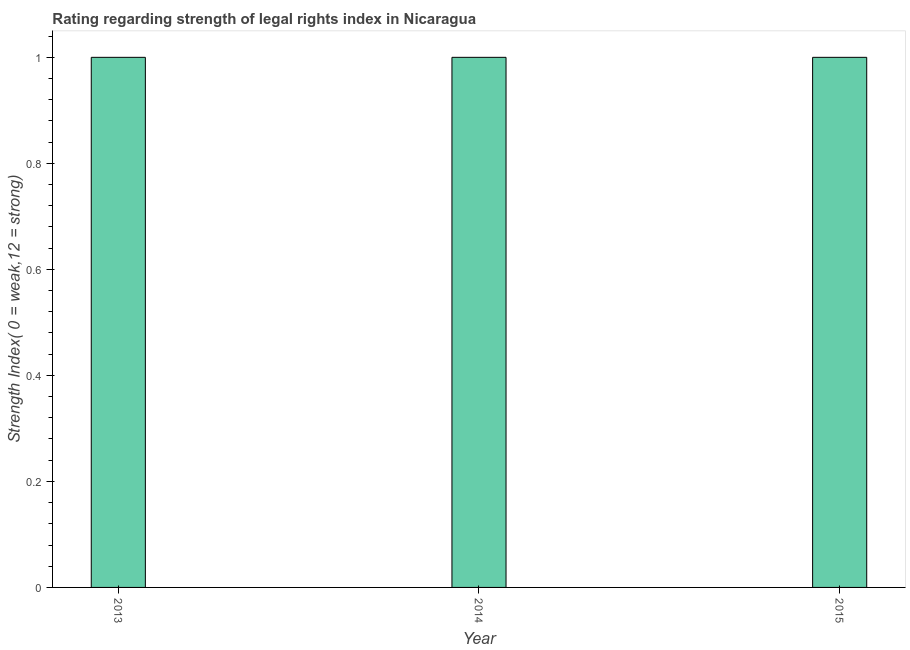Does the graph contain grids?
Offer a very short reply. No. What is the title of the graph?
Offer a terse response. Rating regarding strength of legal rights index in Nicaragua. What is the label or title of the X-axis?
Ensure brevity in your answer.  Year. What is the label or title of the Y-axis?
Ensure brevity in your answer.  Strength Index( 0 = weak,12 = strong). Across all years, what is the maximum strength of legal rights index?
Keep it short and to the point. 1. Across all years, what is the minimum strength of legal rights index?
Give a very brief answer. 1. In which year was the strength of legal rights index maximum?
Provide a short and direct response. 2013. What is the average strength of legal rights index per year?
Your answer should be very brief. 1. In how many years, is the strength of legal rights index greater than 0.44 ?
Offer a very short reply. 3. What is the ratio of the strength of legal rights index in 2014 to that in 2015?
Offer a terse response. 1. Is the strength of legal rights index in 2014 less than that in 2015?
Make the answer very short. No. How many bars are there?
Provide a succinct answer. 3. Are all the bars in the graph horizontal?
Make the answer very short. No. What is the difference between two consecutive major ticks on the Y-axis?
Give a very brief answer. 0.2. Are the values on the major ticks of Y-axis written in scientific E-notation?
Provide a succinct answer. No. What is the Strength Index( 0 = weak,12 = strong) in 2015?
Your answer should be compact. 1. What is the difference between the Strength Index( 0 = weak,12 = strong) in 2013 and 2015?
Give a very brief answer. 0. What is the ratio of the Strength Index( 0 = weak,12 = strong) in 2013 to that in 2014?
Provide a short and direct response. 1. What is the ratio of the Strength Index( 0 = weak,12 = strong) in 2013 to that in 2015?
Your response must be concise. 1. What is the ratio of the Strength Index( 0 = weak,12 = strong) in 2014 to that in 2015?
Ensure brevity in your answer.  1. 